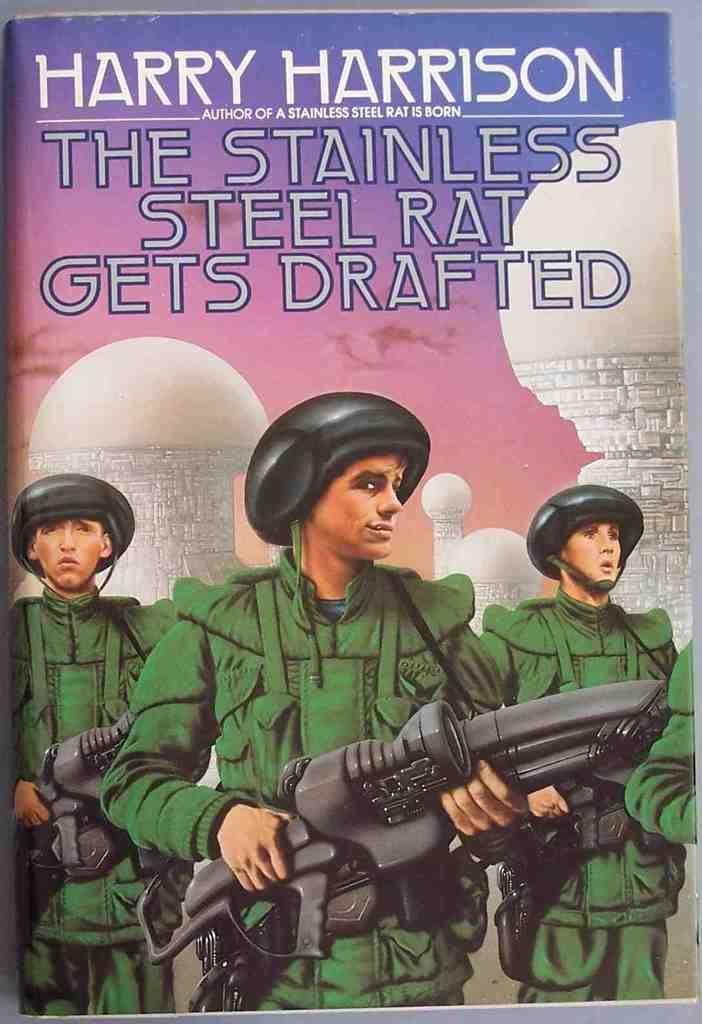How many people are in the image? There are three men in the image. What are the men holding in the image? The men are holding weapons in the image. What color are the coats that the men are wearing? The men are wearing green color coats. What type of headgear are the men wearing? The men are wearing helmets in the image. What type of brush is the man on the left using to paint the wall in the image? There is no brush or wall present in the image; the men are holding weapons and wearing green color coats and helmets. 